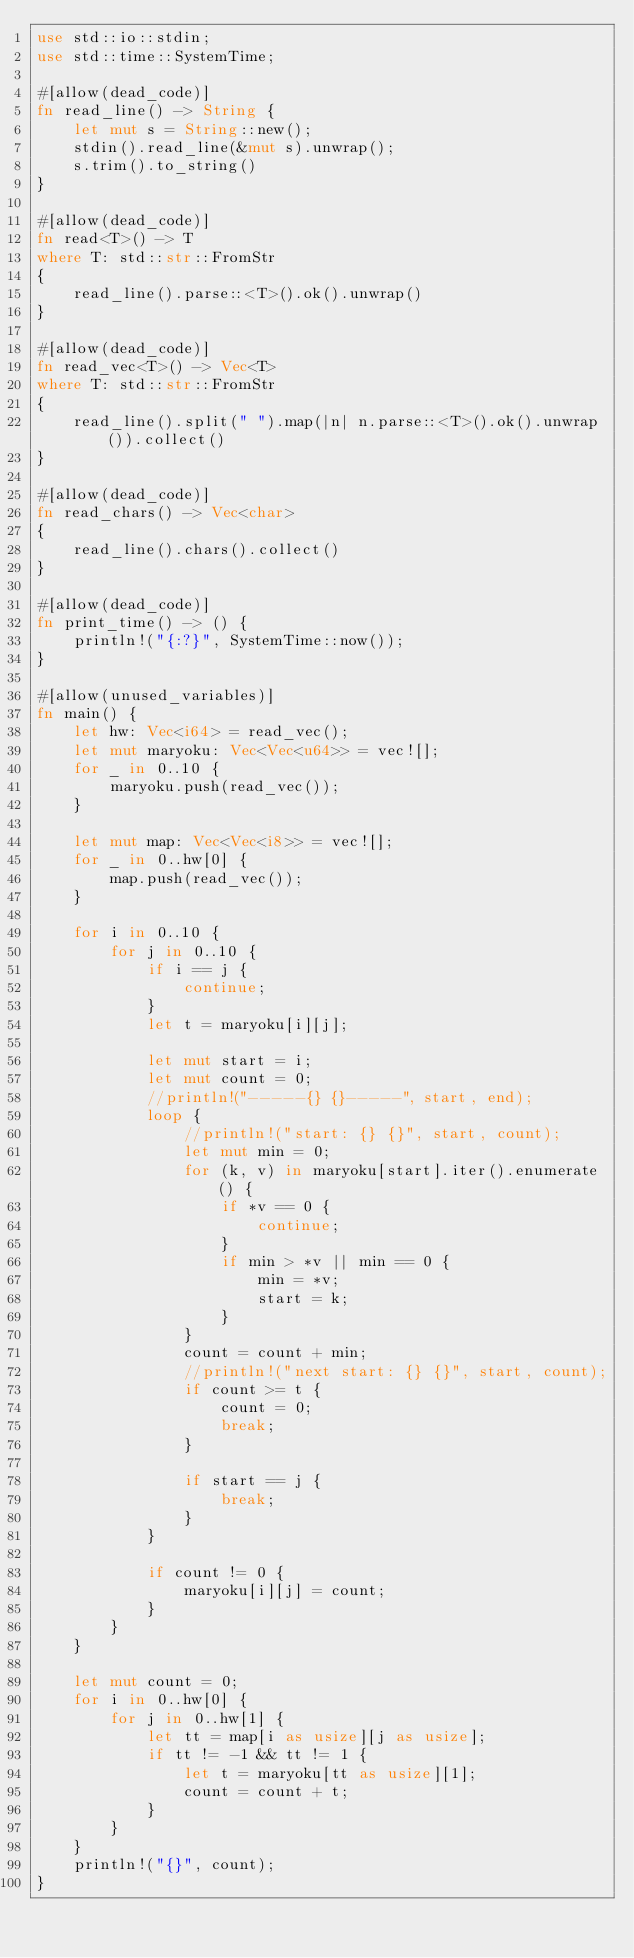<code> <loc_0><loc_0><loc_500><loc_500><_Rust_>use std::io::stdin;
use std::time::SystemTime;

#[allow(dead_code)]
fn read_line() -> String {
    let mut s = String::new();
    stdin().read_line(&mut s).unwrap();
    s.trim().to_string()
}

#[allow(dead_code)]
fn read<T>() -> T
where T: std::str::FromStr
{
    read_line().parse::<T>().ok().unwrap()
}

#[allow(dead_code)]
fn read_vec<T>() -> Vec<T>
where T: std::str::FromStr
{
    read_line().split(" ").map(|n| n.parse::<T>().ok().unwrap()).collect()
}

#[allow(dead_code)]
fn read_chars() -> Vec<char>
{
    read_line().chars().collect()
}

#[allow(dead_code)]
fn print_time() -> () {
    println!("{:?}", SystemTime::now());
}

#[allow(unused_variables)]
fn main() {
    let hw: Vec<i64> = read_vec();
    let mut maryoku: Vec<Vec<u64>> = vec![];
    for _ in 0..10 {
        maryoku.push(read_vec());
    }
    
    let mut map: Vec<Vec<i8>> = vec![];
    for _ in 0..hw[0] {
        map.push(read_vec());
    }
    
    for i in 0..10 {
        for j in 0..10 {
            if i == j {
                continue;
            }
            let t = maryoku[i][j];
            
            let mut start = i;
            let mut count = 0;
            //println!("-----{} {}-----", start, end);
            loop {
                //println!("start: {} {}", start, count);
                let mut min = 0;
                for (k, v) in maryoku[start].iter().enumerate() {
                    if *v == 0 {
                        continue;
                    }
                    if min > *v || min == 0 {
                        min = *v;
                        start = k;
                    }
                }
                count = count + min;
                //println!("next start: {} {}", start, count);
                if count >= t {
                    count = 0;
                    break;
                }
                
                if start == j {
                    break;
                }
            }
            
            if count != 0 {
                maryoku[i][j] = count;
            }
        }
    }
    
    let mut count = 0;
    for i in 0..hw[0] {
        for j in 0..hw[1] {
            let tt = map[i as usize][j as usize];
            if tt != -1 && tt != 1 {
                let t = maryoku[tt as usize][1];
                count = count + t;
            }
        }
    }
    println!("{}", count);
}
</code> 